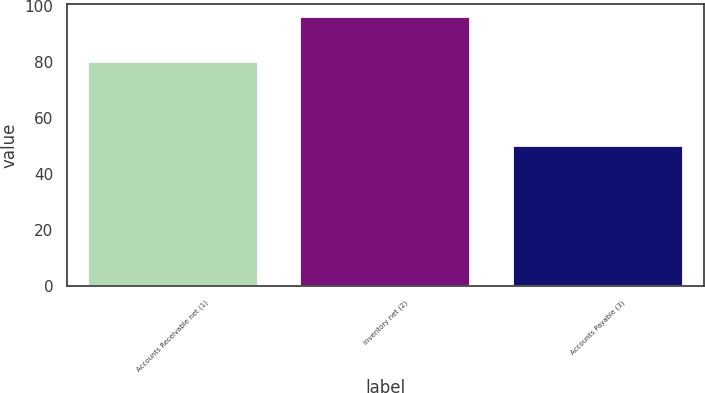<chart> <loc_0><loc_0><loc_500><loc_500><bar_chart><fcel>Accounts Receivable net (1)<fcel>Inventory net (2)<fcel>Accounts Payable (3)<nl><fcel>80<fcel>96<fcel>50<nl></chart> 